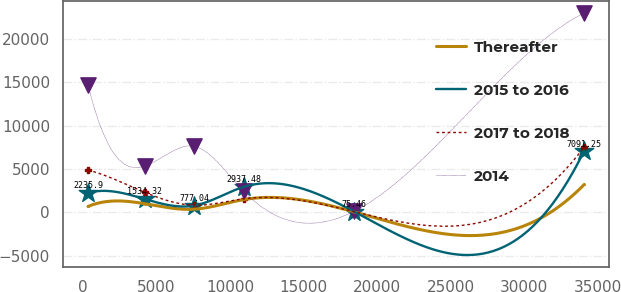Convert chart. <chart><loc_0><loc_0><loc_500><loc_500><line_chart><ecel><fcel>Thereafter<fcel>2015 to 2016<fcel>2017 to 2018<fcel>2014<nl><fcel>355.63<fcel>677.25<fcel>2235.9<fcel>4877.74<fcel>14707.7<nl><fcel>4205.98<fcel>993.56<fcel>1534.32<fcel>2310.39<fcel>5324.15<nl><fcel>7576.96<fcel>360.94<fcel>777.04<fcel>816.58<fcel>7608.61<nl><fcel>10947.9<fcel>1470.84<fcel>2937.48<fcel>1563.49<fcel>2409.62<nl><fcel>18444.9<fcel>44.63<fcel>75.46<fcel>69.67<fcel>125.16<nl><fcel>34065.4<fcel>3207.75<fcel>7091.25<fcel>7538.72<fcel>22969.8<nl></chart> 